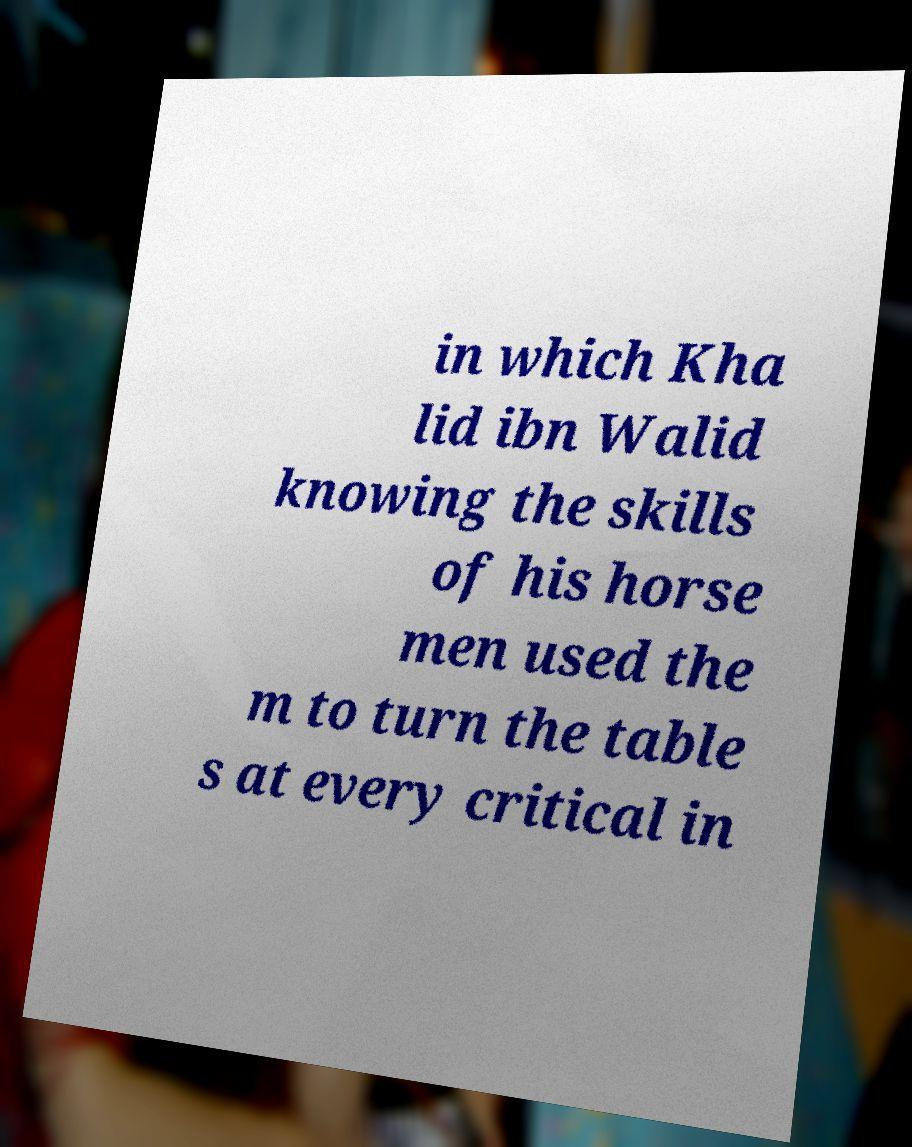There's text embedded in this image that I need extracted. Can you transcribe it verbatim? in which Kha lid ibn Walid knowing the skills of his horse men used the m to turn the table s at every critical in 